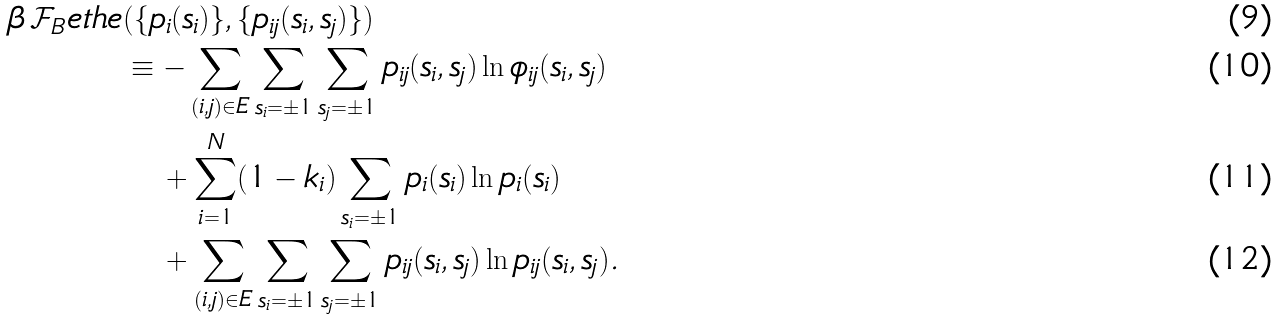<formula> <loc_0><loc_0><loc_500><loc_500>\beta \, \mathcal { F } _ { B } e t h e & ( \{ p _ { i } ( s _ { i } ) \} , \{ p _ { i j } ( s _ { i } , s _ { j } ) \} ) \\ & \equiv - \sum _ { ( i , j ) \in E } \sum _ { s _ { i } = \pm 1 } \sum _ { s _ { j } = \pm 1 } p _ { i j } ( s _ { i } , s _ { j } ) \ln \phi _ { i j } ( s _ { i } , s _ { j } ) \\ & \quad + \sum _ { i = 1 } ^ { N } ( 1 - k _ { i } ) \sum _ { s _ { i } = \pm 1 } p _ { i } ( s _ { i } ) \ln p _ { i } ( s _ { i } ) \\ & \quad + \sum _ { ( i , j ) \in E } \sum _ { s _ { i } = \pm 1 } \sum _ { s _ { j } = \pm 1 } p _ { i j } ( s _ { i } , s _ { j } ) \ln p _ { i j } ( s _ { i } , s _ { j } ) .</formula> 